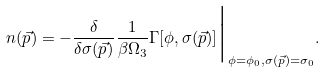<formula> <loc_0><loc_0><loc_500><loc_500>n ( \vec { p } ) = - \frac { \delta } { \delta \sigma ( \vec { p } ) } \frac { 1 } { \beta \Omega _ { 3 } } \Gamma [ \phi , \sigma ( \vec { p } ) ] { \Big | } _ { \phi = \phi _ { 0 } , \sigma ( \vec { p } ) = \sigma _ { 0 } } .</formula> 